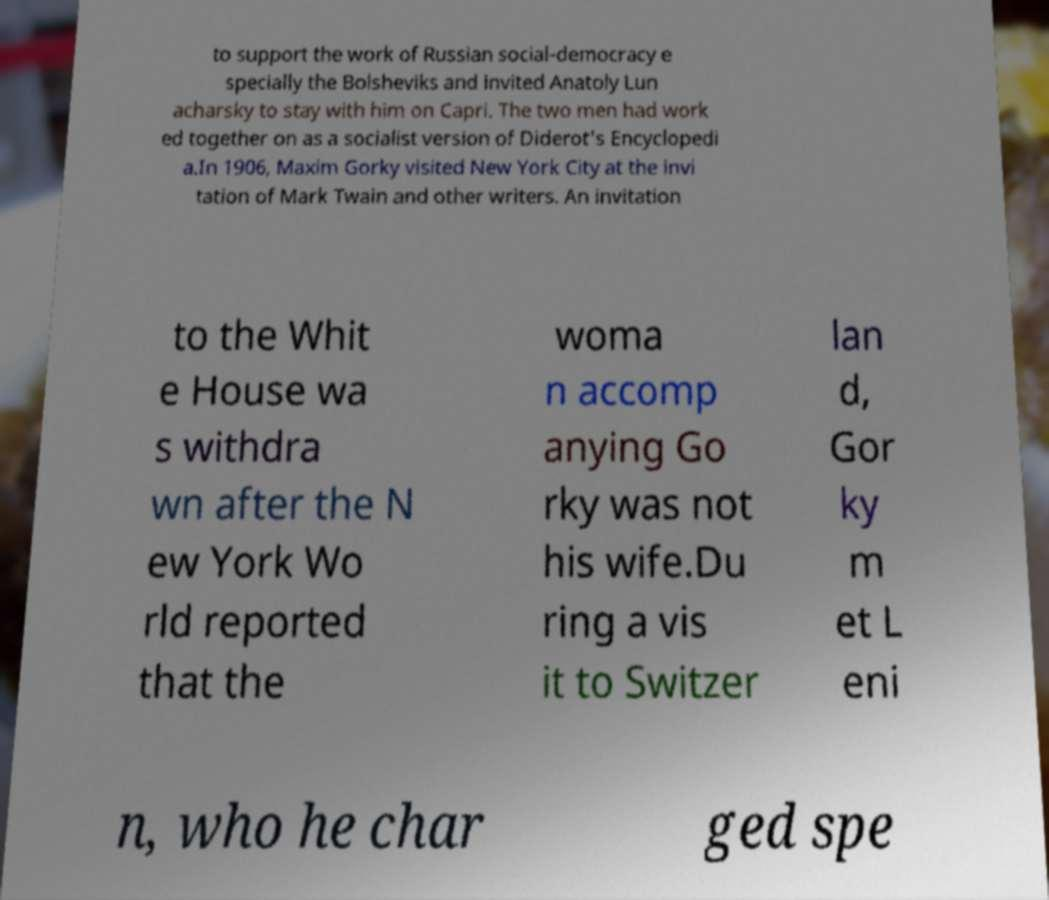Can you read and provide the text displayed in the image?This photo seems to have some interesting text. Can you extract and type it out for me? to support the work of Russian social-democracy e specially the Bolsheviks and invited Anatoly Lun acharsky to stay with him on Capri. The two men had work ed together on as a socialist version of Diderot's Encyclopedi a.In 1906, Maxim Gorky visited New York City at the invi tation of Mark Twain and other writers. An invitation to the Whit e House wa s withdra wn after the N ew York Wo rld reported that the woma n accomp anying Go rky was not his wife.Du ring a vis it to Switzer lan d, Gor ky m et L eni n, who he char ged spe 